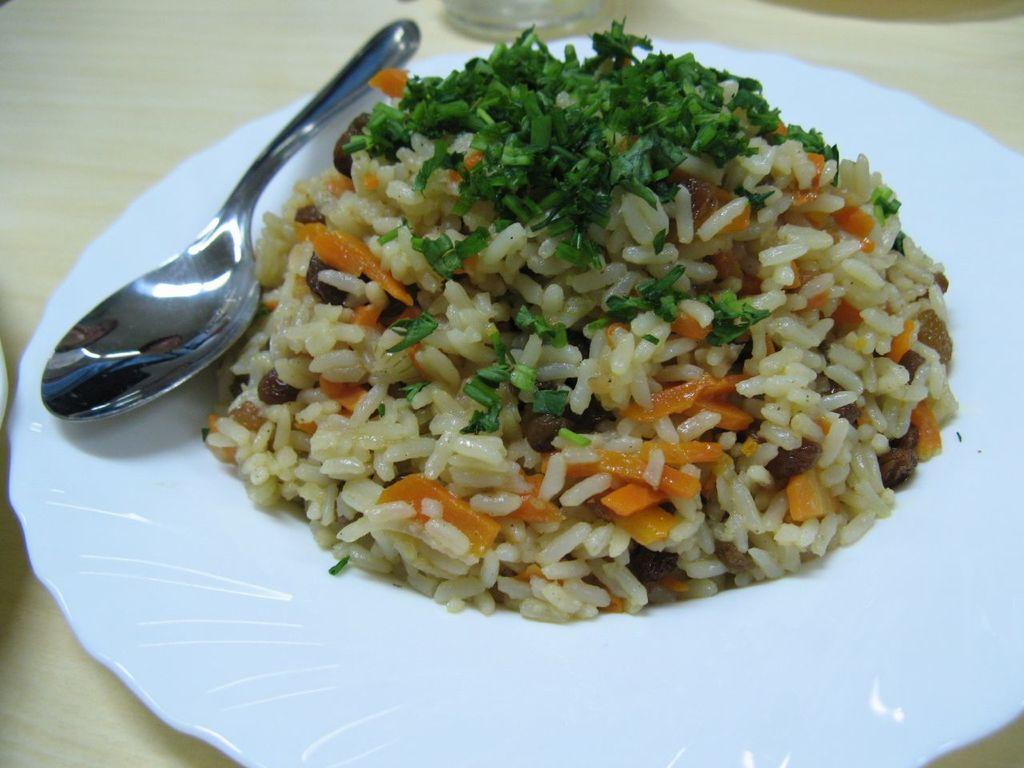What is the main object in the center of the image? There is a table in the center of the image. What can be found on the table? There is a glass, a plate of food, and a spoon on the table. Is the maid pulling the net in the image? There is no maid or net present in the image. 